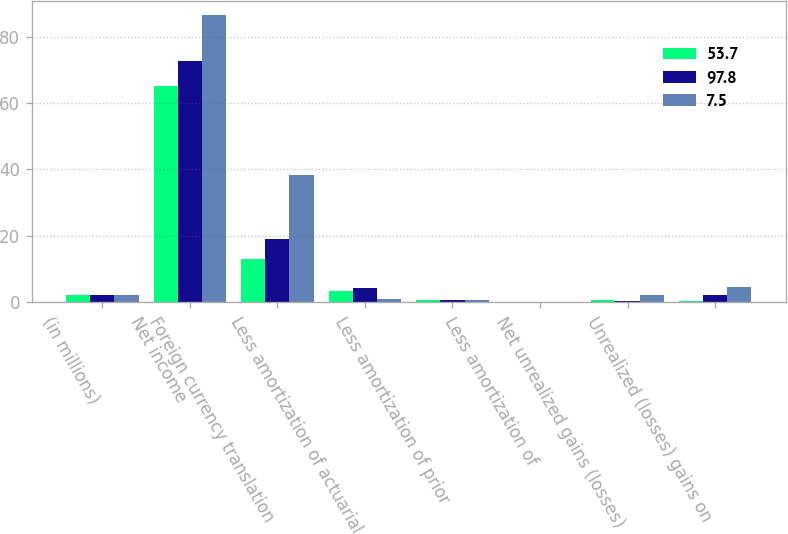Convert chart to OTSL. <chart><loc_0><loc_0><loc_500><loc_500><stacked_bar_chart><ecel><fcel>(in millions)<fcel>Net income<fcel>Foreign currency translation<fcel>Less amortization of actuarial<fcel>Less amortization of prior<fcel>Less amortization of<fcel>Net unrealized gains (losses)<fcel>Unrealized (losses) gains on<nl><fcel>53.7<fcel>2<fcel>65.3<fcel>13<fcel>3.4<fcel>0.6<fcel>0.1<fcel>0.6<fcel>0.3<nl><fcel>97.8<fcel>2<fcel>72.6<fcel>19<fcel>4.3<fcel>0.6<fcel>0.1<fcel>0.4<fcel>2<nl><fcel>7.5<fcel>2<fcel>86.6<fcel>38.3<fcel>1<fcel>0.6<fcel>0.1<fcel>2.2<fcel>4.4<nl></chart> 